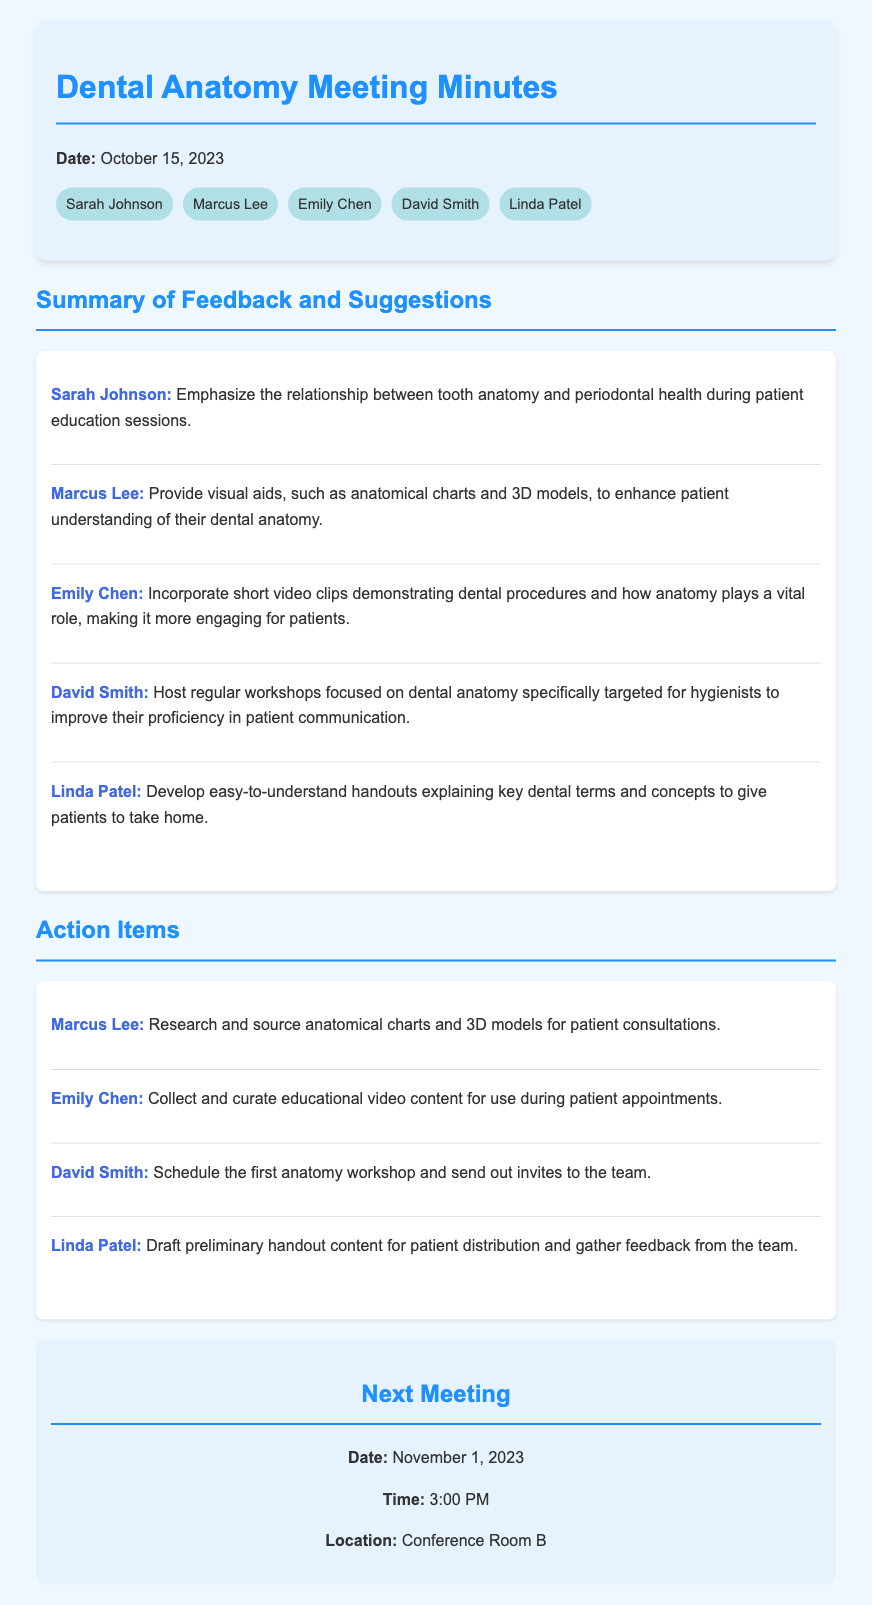What is the date of the meeting? The meeting date is mentioned at the beginning of the document.
Answer: October 15, 2023 Who suggested using anatomical charts? This feedback item is specifically attributed to Marcus Lee.
Answer: Marcus Lee What is one way Emily Chen suggested engaging patients? By incorporating short video clips related to dental procedures.
Answer: Short video clips How many attendees are listed in the document? The number of attendees is counted from the attendee section.
Answer: 5 What action item is assigned to David Smith? This item specifies hosting workshops for hygienists.
Answer: Schedule the first anatomy workshop Why is anatomical knowledge emphasized in the suggestions? The focus on dental anatomy helps improve patient interactions and communication.
Answer: Improve patient interactions When is the next meeting scheduled? The date for the next meeting is provided in the document.
Answer: November 1, 2023 What type of educational resources did Linda Patel suggest creating? The suggestion involves handouts to explain dental terms.
Answer: Easy-to-understand handouts Who is responsible for researching anatomical models? This responsibility is explicitly stated in the action items.
Answer: Marcus Lee 